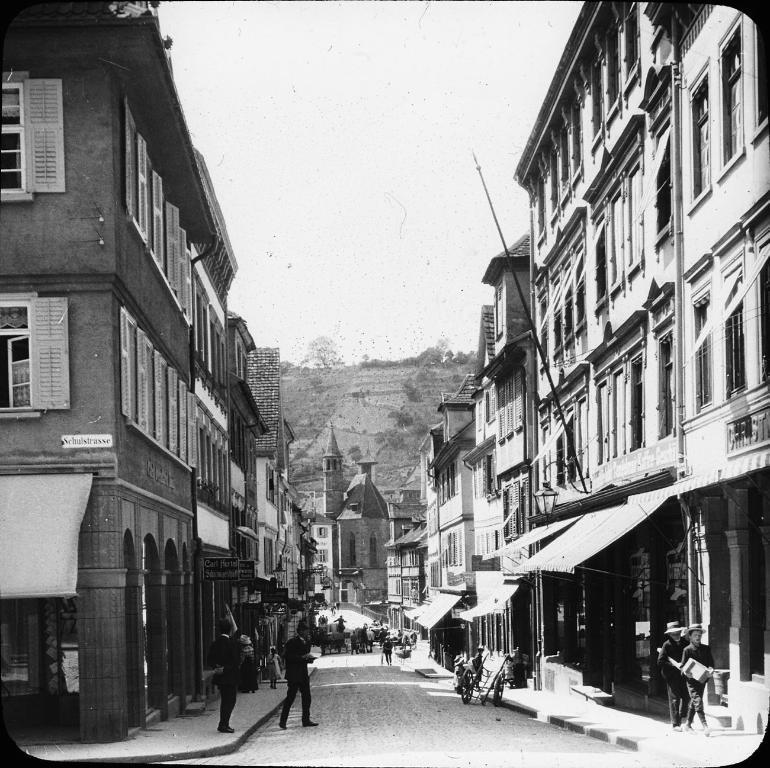Please provide a concise description of this image. To the left side of the image there is a building with walls, windows, tent and pillars and name boards. To the right side of the image there are buildings with walls, windows and few other items. In the background there are trees and buildings. To the middle top of the image there is a sky. 